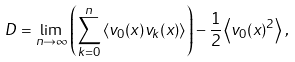Convert formula to latex. <formula><loc_0><loc_0><loc_500><loc_500>D = \lim _ { n \to \infty } \left ( \sum _ { k = 0 } ^ { n } \left \langle v _ { 0 } ( x ) v _ { k } ( x ) \right \rangle \right ) - \frac { 1 } { 2 } \left \langle v _ { 0 } ( x ) ^ { 2 } \right \rangle \, ,</formula> 